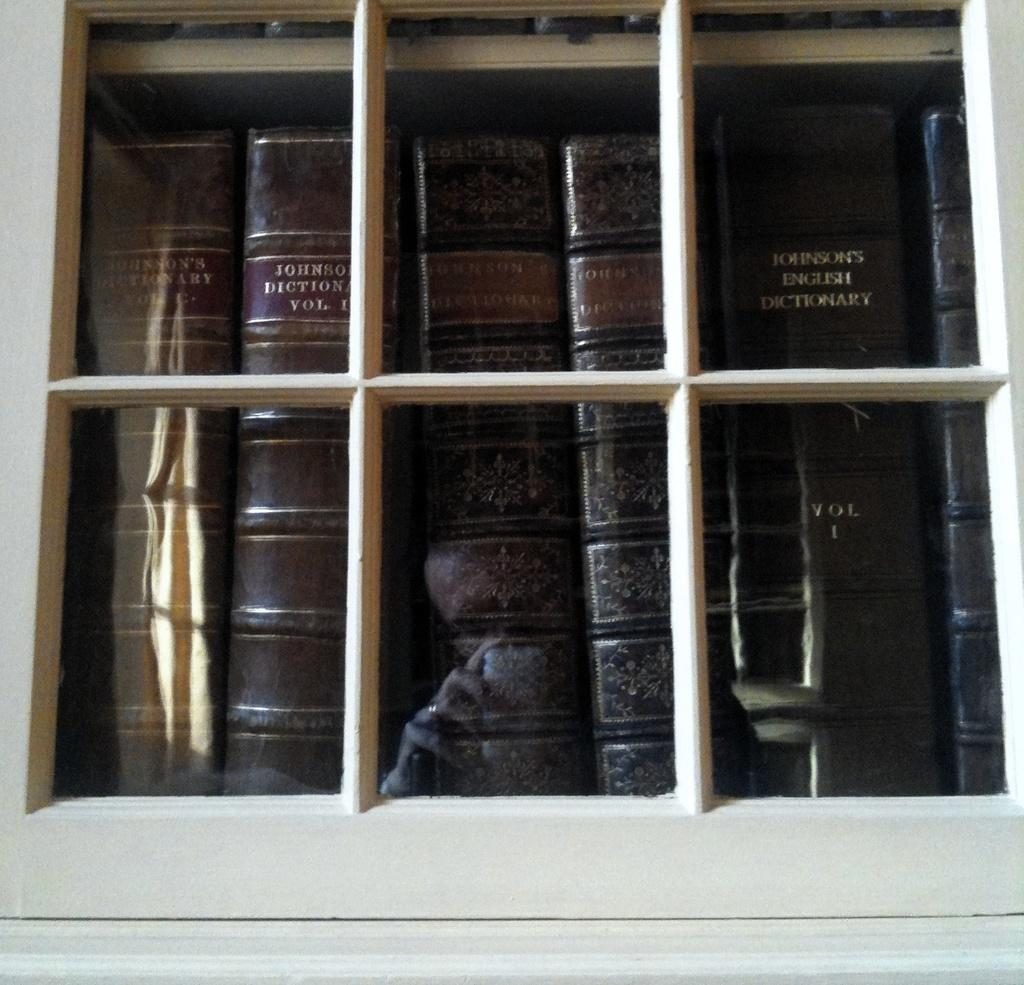<image>
Relay a brief, clear account of the picture shown. A stack of leather bound dictionaries behind a glass window. 